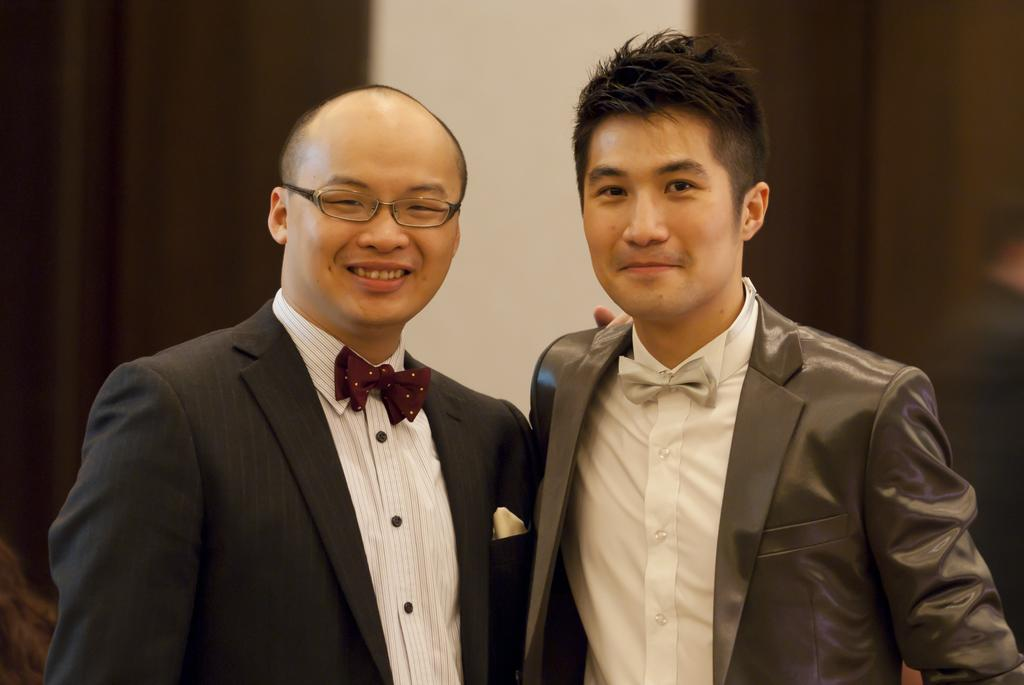How many people are in the image? There are two people in the image. What colors are the people wearing? The people are wearing white, black, and grey color dresses. What can be seen in the background of the image? There are curtains and a wall visible in the background of the image. What type of orange fruit is the doctor holding in the image? There is no doctor or orange fruit present in the image. Is the person on the left the brother of the person on the right? The provided facts do not mention any familial relationships between the two people in the image. 